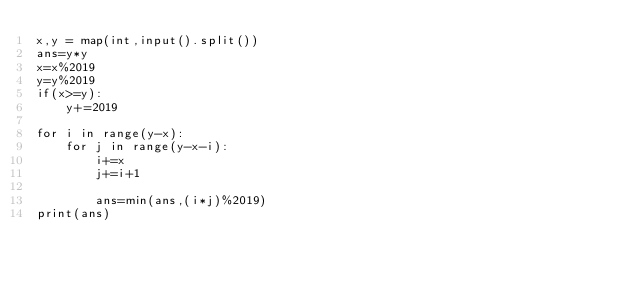Convert code to text. <code><loc_0><loc_0><loc_500><loc_500><_Python_>x,y = map(int,input().split())
ans=y*y
x=x%2019
y=y%2019
if(x>=y):
    y+=2019

for i in range(y-x):
    for j in range(y-x-i):
        i+=x
        j+=i+1
        
        ans=min(ans,(i*j)%2019)
print(ans)
        </code> 